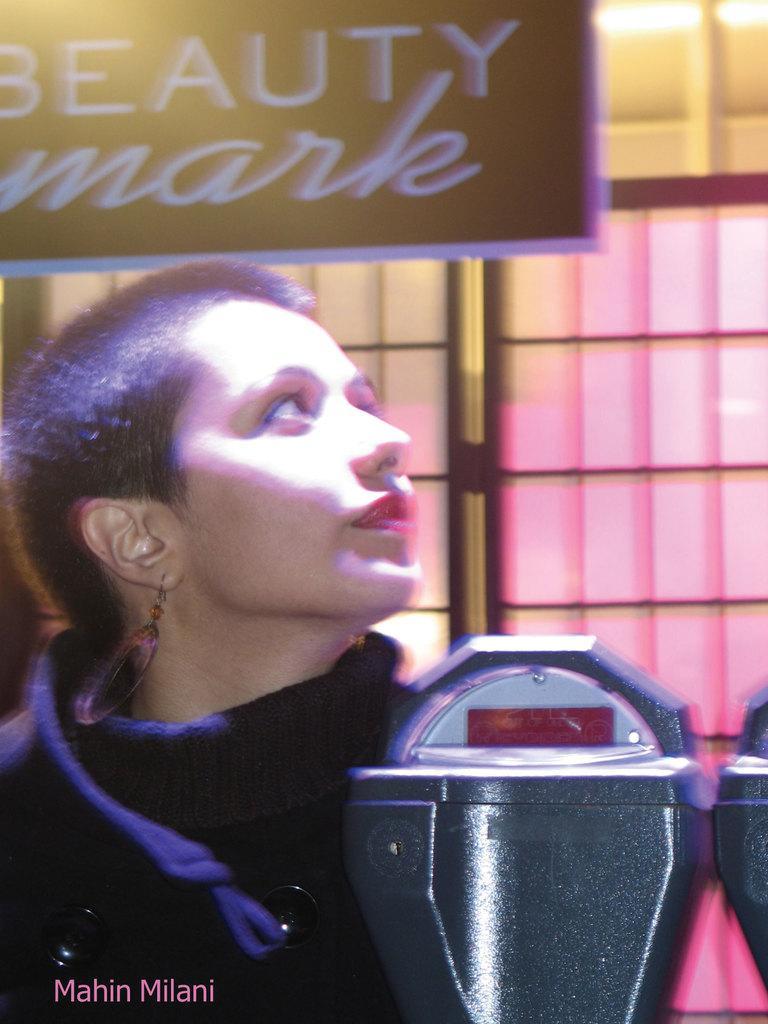Could you give a brief overview of what you see in this image? In this image we can see a woman and some objects beside her. We can also see a window and a board with some text on it. 